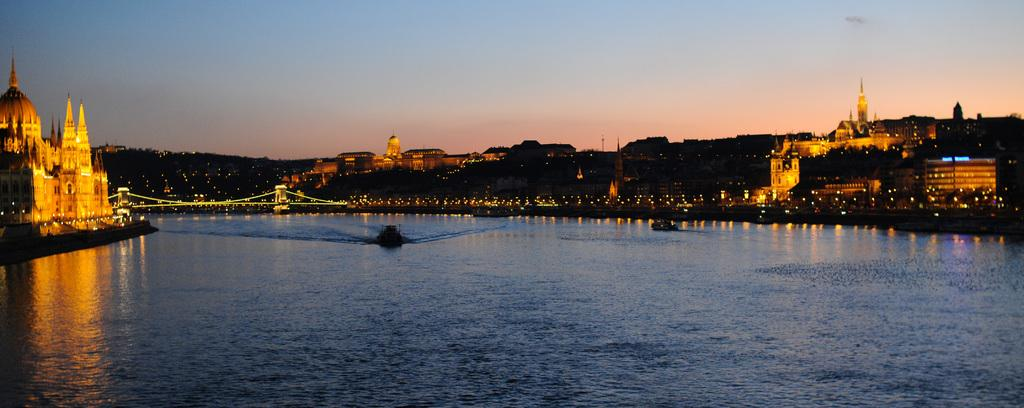What type of structures can be seen in the image? There are buildings and a bridge in the image. What is present in the water in the image? There are boats in the water in the image. Are the buildings and bridge illuminated in any way? Yes, the buildings and bridge have lighting. What color is the sky in the image? The sky is blue in the image. Can you see any cobwebs on the bridge in the image? There is no mention of cobwebs in the image, so we cannot determine if they are present or not. 